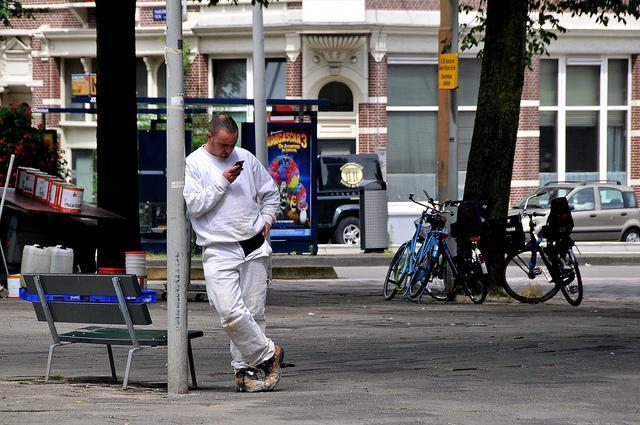How many bicycles are there?
Give a very brief answer. 4. How many cars are there?
Give a very brief answer. 2. 